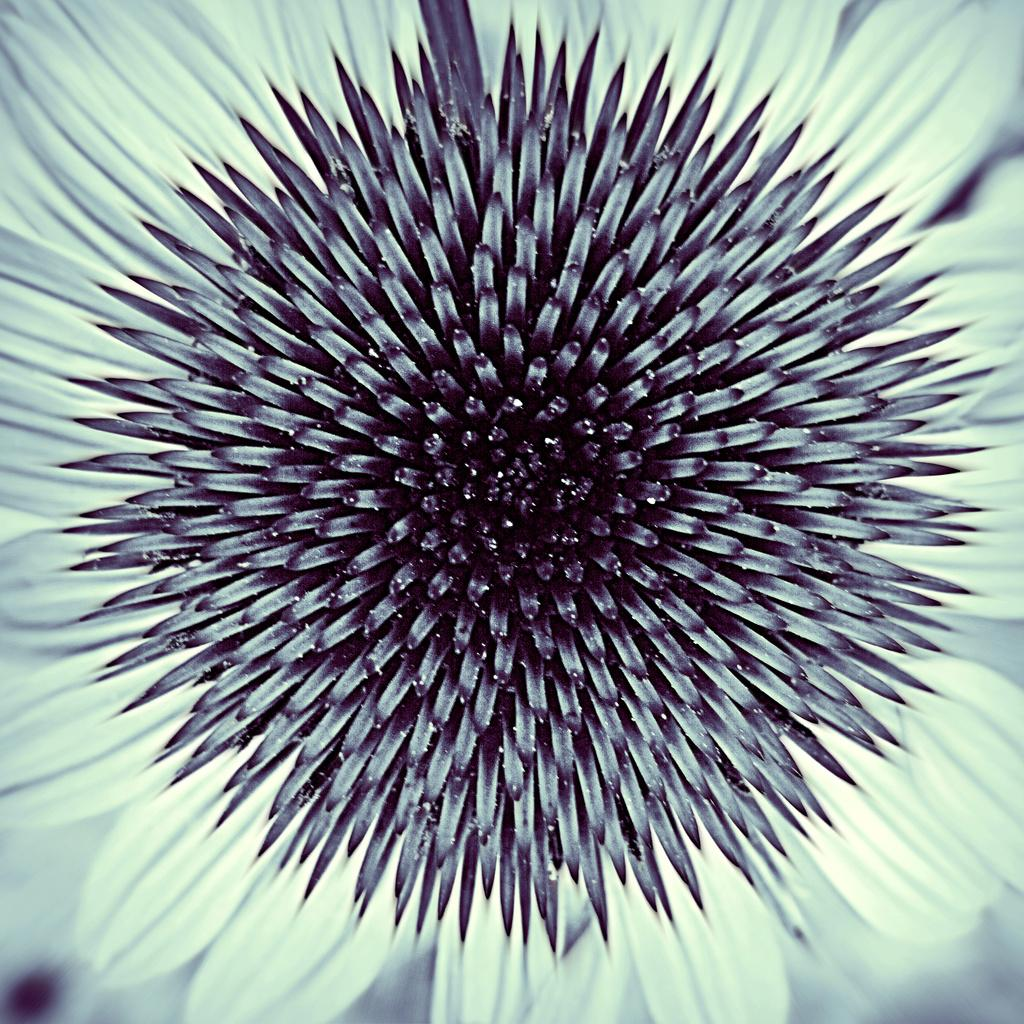What is the main subject of the image? There is a sunflower in the center of the image. Can you describe the sunflower in more detail? The sunflower has yellow petals and a brown center. What type of plant is a sunflower? A sunflower is a flowering plant that belongs to the family Asteraceae. What flavor of beans can be seen growing on the sunflower in the image? There are no beans present in the image, and sunflowers do not produce beans. 